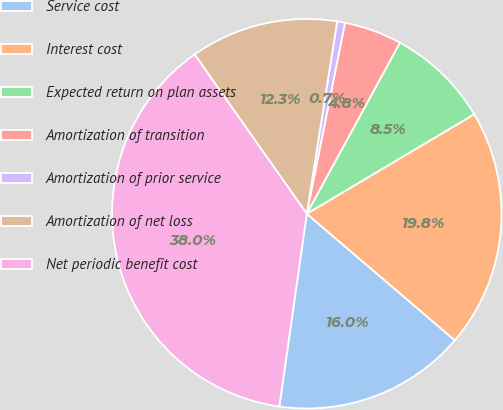Convert chart to OTSL. <chart><loc_0><loc_0><loc_500><loc_500><pie_chart><fcel>Service cost<fcel>Interest cost<fcel>Expected return on plan assets<fcel>Amortization of transition<fcel>Amortization of prior service<fcel>Amortization of net loss<fcel>Net periodic benefit cost<nl><fcel>15.99%<fcel>19.79%<fcel>8.53%<fcel>4.79%<fcel>0.65%<fcel>12.26%<fcel>37.98%<nl></chart> 